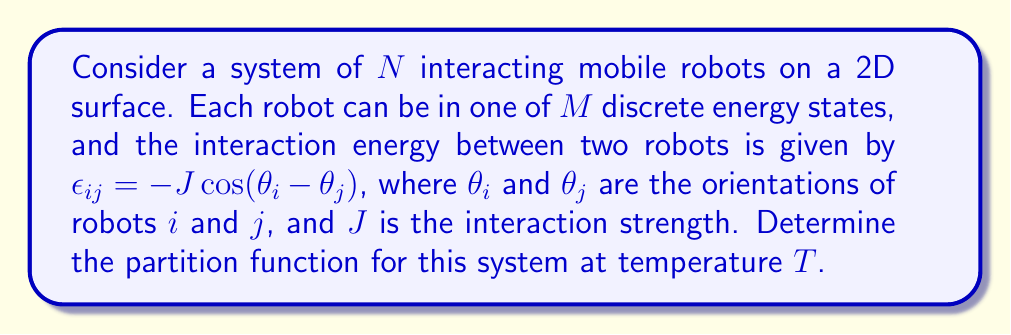Can you answer this question? To solve this problem, we'll follow these steps:

1) The partition function $Z$ for a system of $N$ particles is given by:

   $$Z = \sum_{\text{all states}} e^{-\beta E}$$

   where $\beta = \frac{1}{k_B T}$, $k_B$ is Boltzmann's constant, and $E$ is the total energy of the system.

2) In this case, the total energy includes both the individual robot energies and the interaction energies:

   $$E = \sum_{i=1}^N E_i + \frac{1}{2}\sum_{i\neq j} \epsilon_{ij}$$

   where $E_i$ is the energy of the $i$-th robot's state.

3) Substituting this into the partition function:

   $$Z = \sum_{\text{all states}} \exp\left(-\beta\left(\sum_{i=1}^N E_i + \frac{1}{2}\sum_{i\neq j} \epsilon_{ij}\right)\right)$$

4) We can separate the individual and interaction terms:

   $$Z = \sum_{\text{all states}} \exp\left(-\beta\sum_{i=1}^N E_i\right) \exp\left(-\beta\frac{1}{2}\sum_{i\neq j} \epsilon_{ij}\right)$$

5) Substituting the interaction energy:

   $$Z = \sum_{\text{all states}} \exp\left(-\beta\sum_{i=1}^N E_i\right) \exp\left(\beta J\frac{1}{2}\sum_{i\neq j} \cos(\theta_i - \theta_j)\right)$$

6) The sum over all states includes both the energy states and orientations of all robots:

   $$Z = \sum_{E_1=1}^M \cdots \sum_{E_N=1}^M \int_0^{2\pi} \cdots \int_0^{2\pi} \exp\left(-\beta\sum_{i=1}^N E_i\right) \exp\left(\beta J\frac{1}{2}\sum_{i\neq j} \cos(\theta_i - \theta_j)\right) d\theta_1 \cdots d\theta_N$$

7) This integral cannot be solved analytically in general. However, it can be approximated using various methods such as mean-field theory or Monte Carlo simulations.
Answer: $$Z = \sum_{E_1=1}^M \cdots \sum_{E_N=1}^M \int_0^{2\pi} \cdots \int_0^{2\pi} \exp\left(-\beta\sum_{i=1}^N E_i\right) \exp\left(\beta J\frac{1}{2}\sum_{i\neq j} \cos(\theta_i - \theta_j)\right) d\theta_1 \cdots d\theta_N$$ 